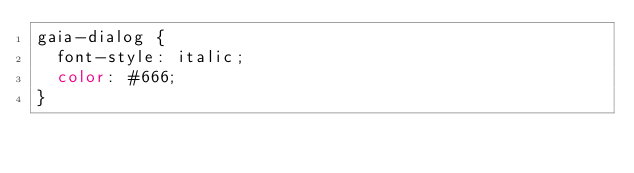Convert code to text. <code><loc_0><loc_0><loc_500><loc_500><_CSS_>gaia-dialog {
  font-style: italic;
  color: #666;
}
</code> 